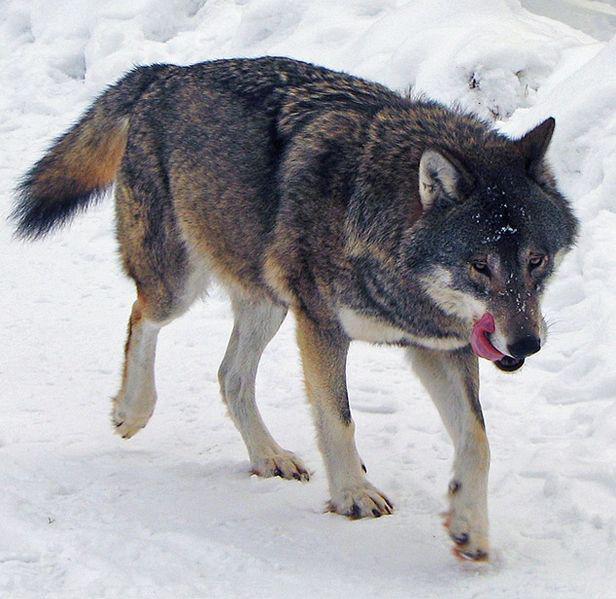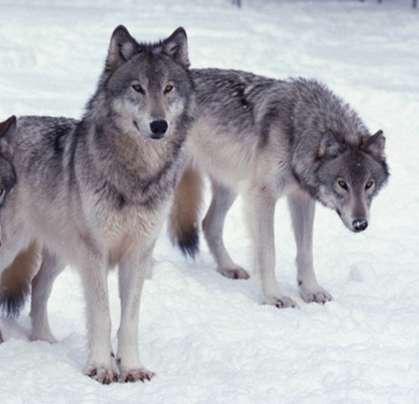The first image is the image on the left, the second image is the image on the right. For the images shown, is this caption "The animal in the image on the left is moving left." true? Answer yes or no. No. 